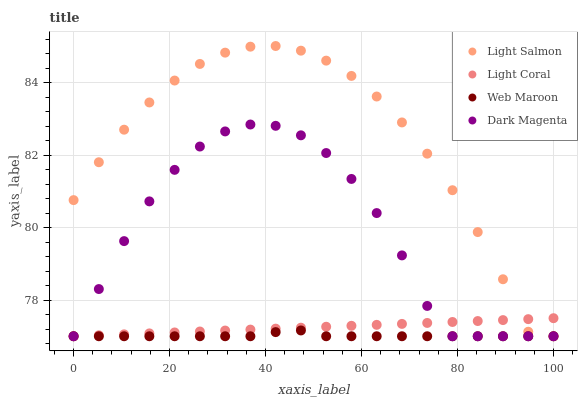Does Web Maroon have the minimum area under the curve?
Answer yes or no. Yes. Does Light Salmon have the maximum area under the curve?
Answer yes or no. Yes. Does Light Salmon have the minimum area under the curve?
Answer yes or no. No. Does Web Maroon have the maximum area under the curve?
Answer yes or no. No. Is Light Coral the smoothest?
Answer yes or no. Yes. Is Dark Magenta the roughest?
Answer yes or no. Yes. Is Light Salmon the smoothest?
Answer yes or no. No. Is Light Salmon the roughest?
Answer yes or no. No. Does Light Coral have the lowest value?
Answer yes or no. Yes. Does Light Salmon have the highest value?
Answer yes or no. Yes. Does Web Maroon have the highest value?
Answer yes or no. No. Does Light Salmon intersect Dark Magenta?
Answer yes or no. Yes. Is Light Salmon less than Dark Magenta?
Answer yes or no. No. Is Light Salmon greater than Dark Magenta?
Answer yes or no. No. 